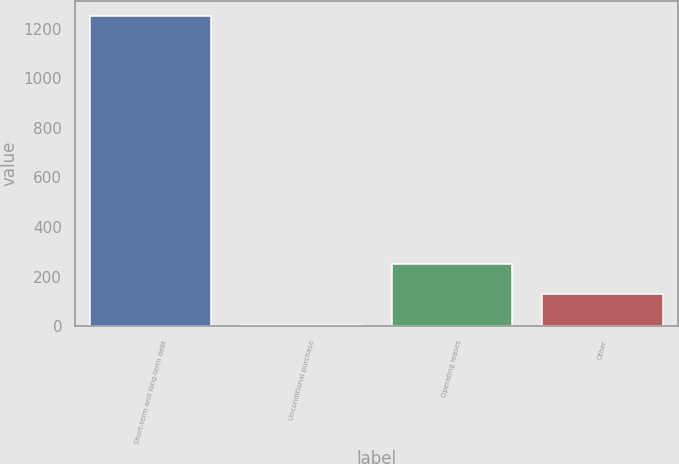<chart> <loc_0><loc_0><loc_500><loc_500><bar_chart><fcel>Short-term and long-term debt<fcel>Unconditional purchase<fcel>Operating leases<fcel>Other<nl><fcel>1250<fcel>3<fcel>252.4<fcel>127.7<nl></chart> 